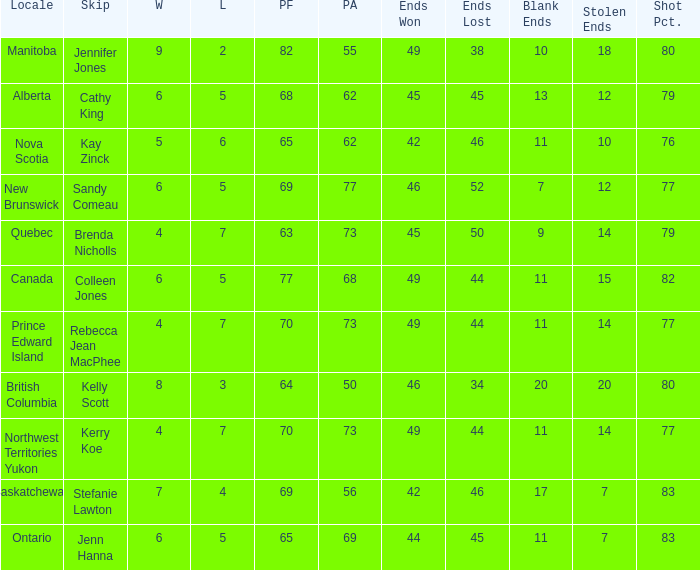What is the minimum PA when ends lost is 45? 62.0. 